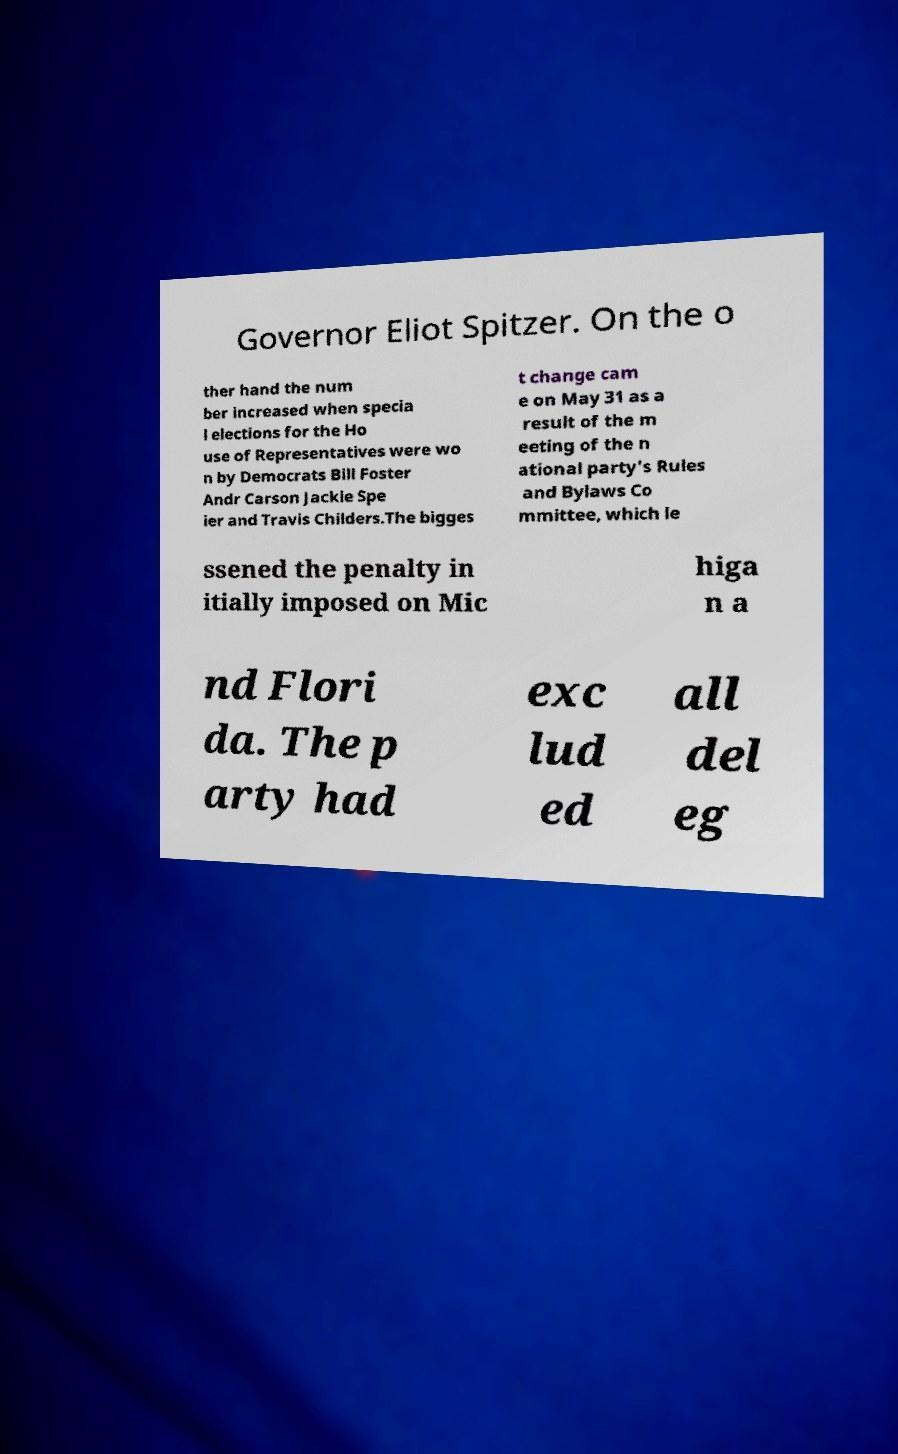There's text embedded in this image that I need extracted. Can you transcribe it verbatim? Governor Eliot Spitzer. On the o ther hand the num ber increased when specia l elections for the Ho use of Representatives were wo n by Democrats Bill Foster Andr Carson Jackie Spe ier and Travis Childers.The bigges t change cam e on May 31 as a result of the m eeting of the n ational party's Rules and Bylaws Co mmittee, which le ssened the penalty in itially imposed on Mic higa n a nd Flori da. The p arty had exc lud ed all del eg 